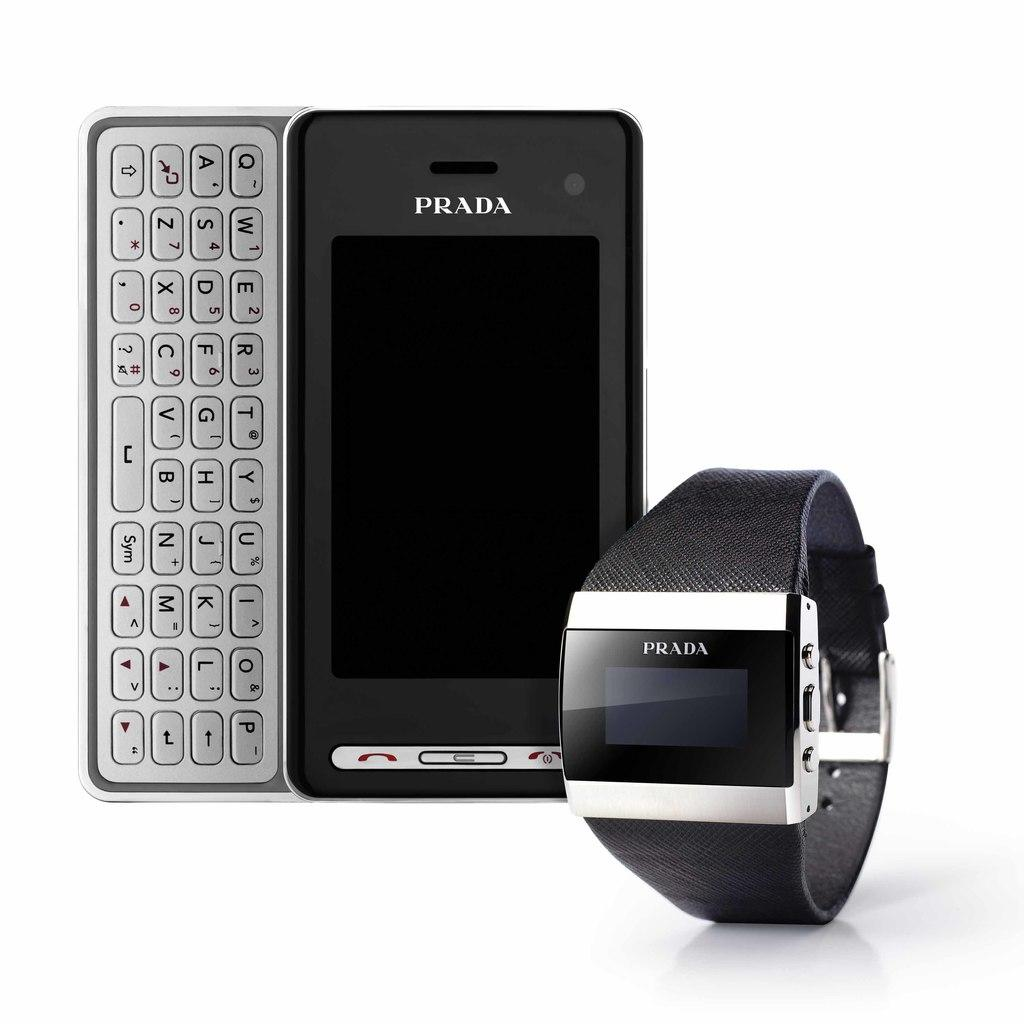<image>
Provide a brief description of the given image. Prada phone and prada smart watch that is sitting in a picture 